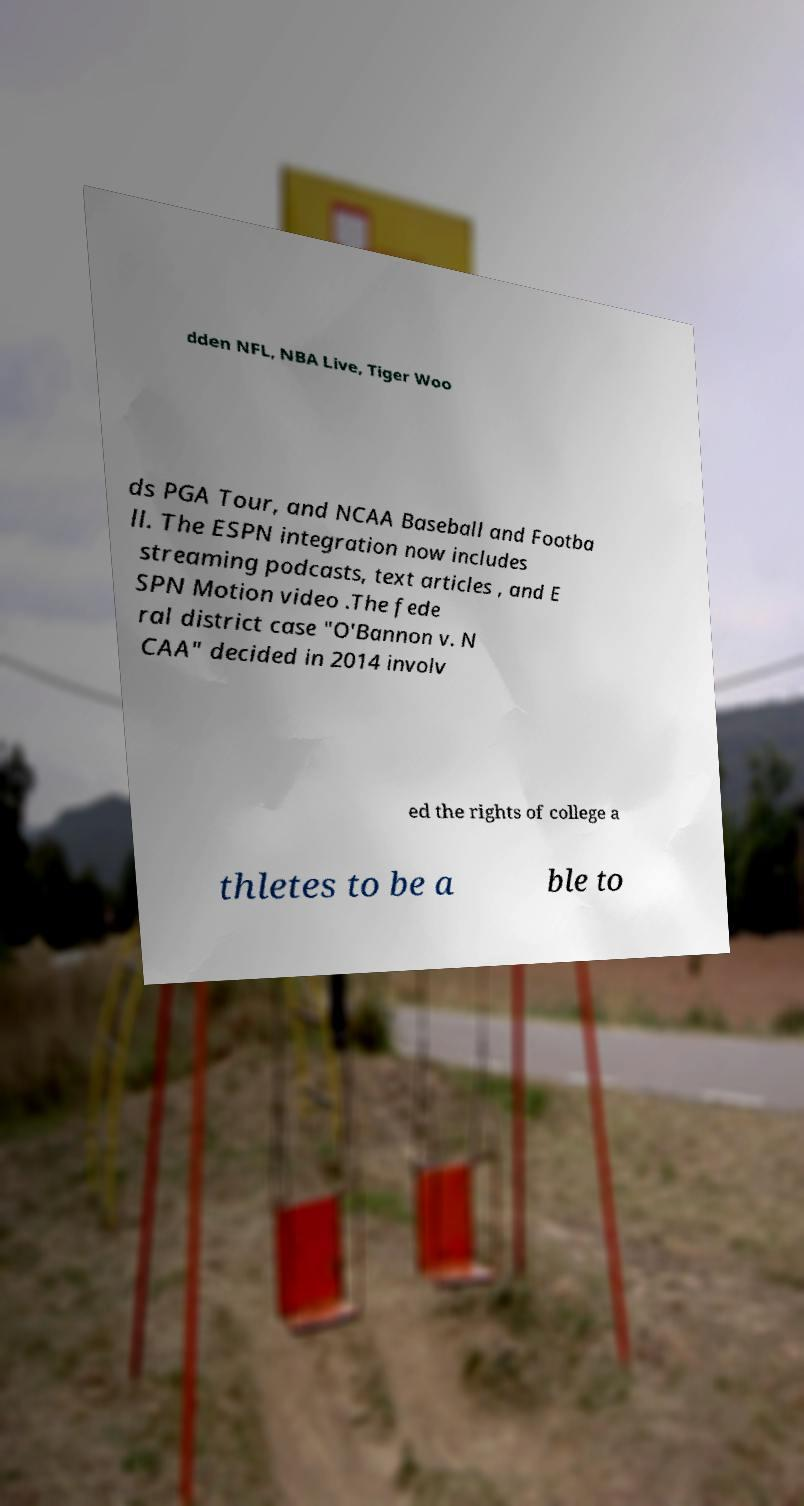For documentation purposes, I need the text within this image transcribed. Could you provide that? dden NFL, NBA Live, Tiger Woo ds PGA Tour, and NCAA Baseball and Footba ll. The ESPN integration now includes streaming podcasts, text articles , and E SPN Motion video .The fede ral district case "O'Bannon v. N CAA" decided in 2014 involv ed the rights of college a thletes to be a ble to 